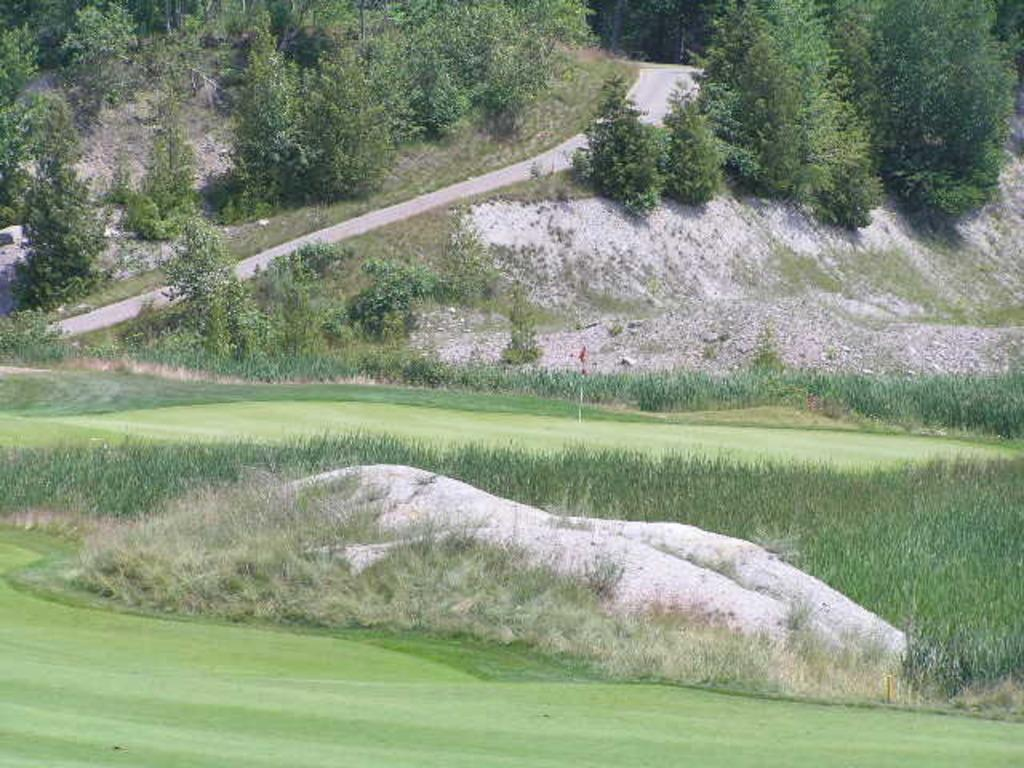What type of location is depicted in the image? There is a golf ground in the image. What can be seen in the background of the image? There is a road, a mountain, and trees visible in the background of the image. What type of vegetation is present on the right side of the image? There are plants and grass on the right side of the image. What is the purpose of the flag in the image? There is a flag on the golf ground, which is likely used to mark a specific location or hole. How many apples are hanging from the trees in the image? There are no apples visible in the image; the trees in the background are not specifically identified as fruit-bearing trees. What type of thread is used to sew the flag in the image? There is no information about the type of thread used to sew the flag in the image, as the focus is on the flag's presence and purpose rather than its construction. 